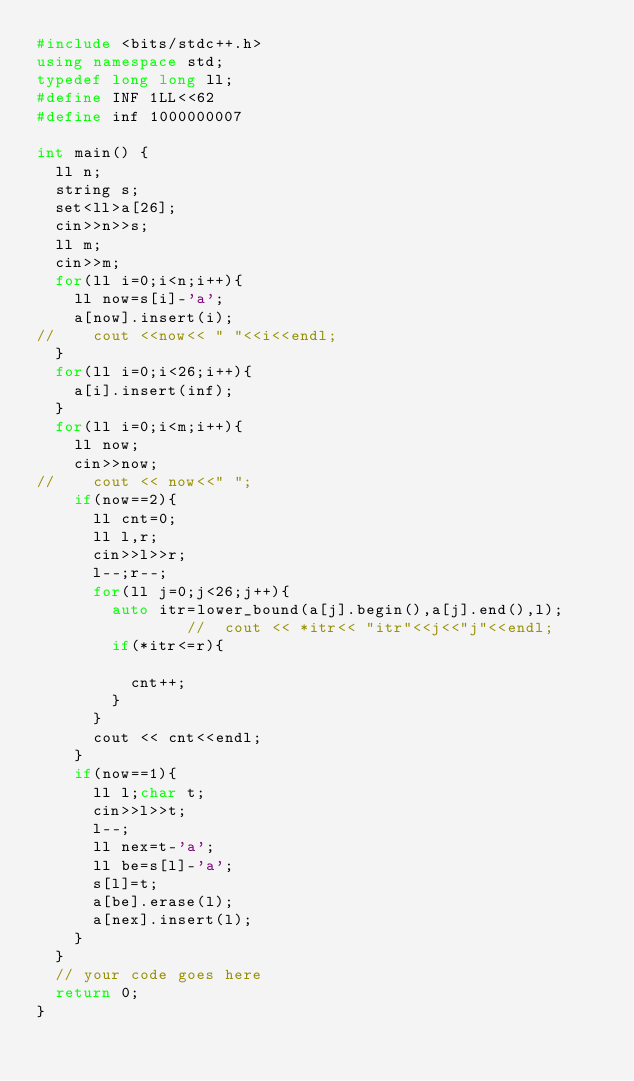<code> <loc_0><loc_0><loc_500><loc_500><_C++_>#include <bits/stdc++.h>
using namespace std;
typedef long long ll;
#define INF 1LL<<62
#define inf 1000000007

int main() {
	ll n;
	string s;
	set<ll>a[26];
	cin>>n>>s;
	ll m;
	cin>>m;
	for(ll i=0;i<n;i++){
		ll now=s[i]-'a';
		a[now].insert(i);
//		cout <<now<< " "<<i<<endl;
	}
	for(ll i=0;i<26;i++){
		a[i].insert(inf);
	}
	for(ll i=0;i<m;i++){
		ll now;
		cin>>now;
//		cout << now<<" ";
		if(now==2){
			ll cnt=0;
			ll l,r;
			cin>>l>>r;
			l--;r--;
			for(ll j=0;j<26;j++){
				auto itr=lower_bound(a[j].begin(),a[j].end(),l);
								//	cout << *itr<< "itr"<<j<<"j"<<endl;
				if(*itr<=r){

					cnt++;
				}
			}
			cout << cnt<<endl;
		}
		if(now==1){
			ll l;char t;
			cin>>l>>t;
			l--;
			ll nex=t-'a';
			ll be=s[l]-'a';
			s[l]=t;
			a[be].erase(l);
			a[nex].insert(l);
		}
	}
	// your code goes here
	return 0;
}</code> 